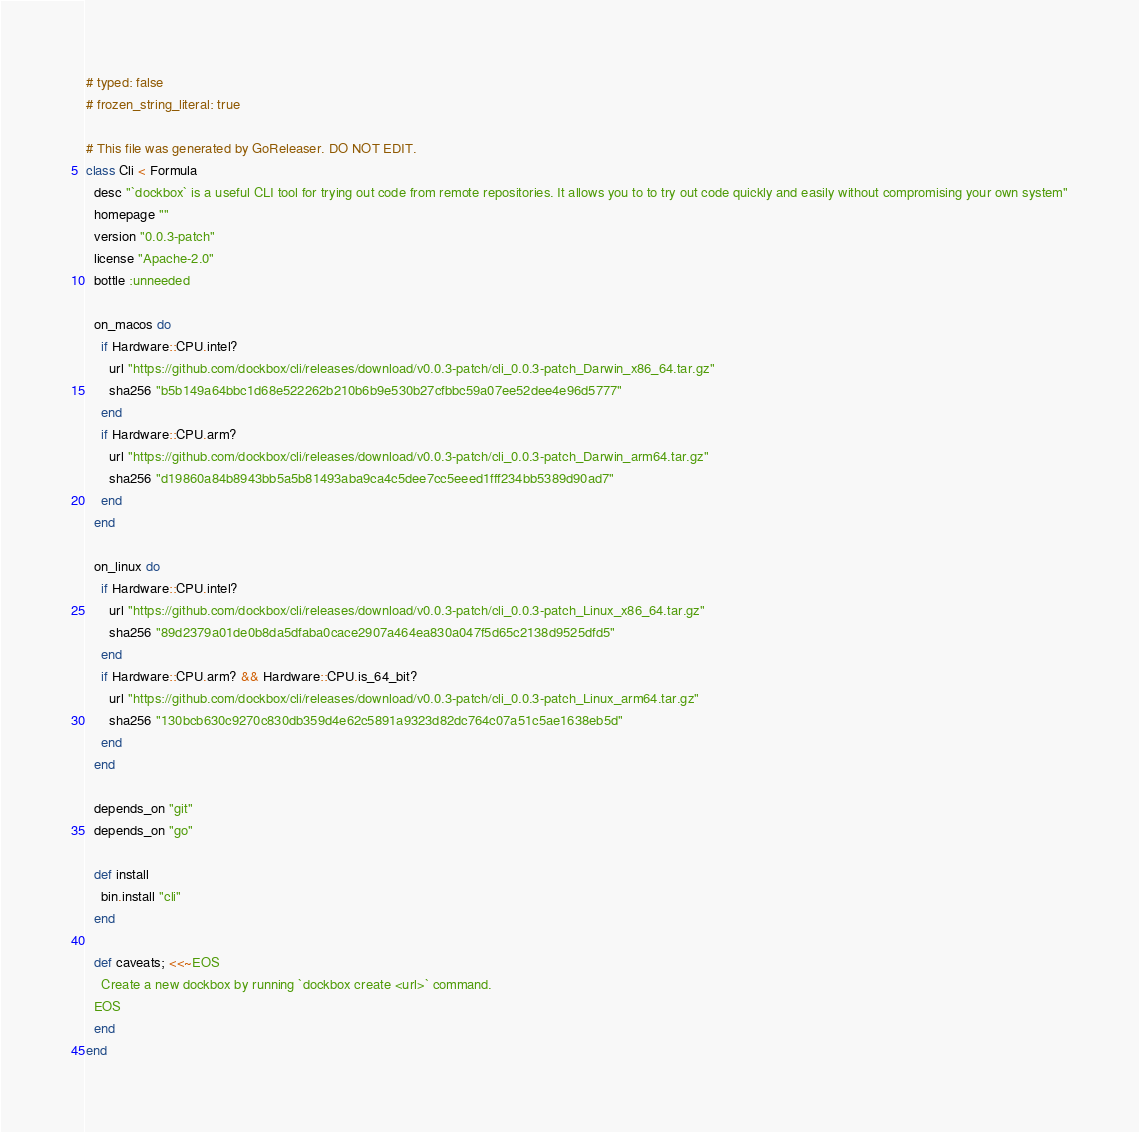Convert code to text. <code><loc_0><loc_0><loc_500><loc_500><_Ruby_># typed: false
# frozen_string_literal: true

# This file was generated by GoReleaser. DO NOT EDIT.
class Cli < Formula
  desc "`dockbox` is a useful CLI tool for trying out code from remote repositories. It allows you to to try out code quickly and easily without compromising your own system"
  homepage ""
  version "0.0.3-patch"
  license "Apache-2.0"
  bottle :unneeded

  on_macos do
    if Hardware::CPU.intel?
      url "https://github.com/dockbox/cli/releases/download/v0.0.3-patch/cli_0.0.3-patch_Darwin_x86_64.tar.gz"
      sha256 "b5b149a64bbc1d68e522262b210b6b9e530b27cfbbc59a07ee52dee4e96d5777"
    end
    if Hardware::CPU.arm?
      url "https://github.com/dockbox/cli/releases/download/v0.0.3-patch/cli_0.0.3-patch_Darwin_arm64.tar.gz"
      sha256 "d19860a84b8943bb5a5b81493aba9ca4c5dee7cc5eeed1fff234bb5389d90ad7"
    end
  end

  on_linux do
    if Hardware::CPU.intel?
      url "https://github.com/dockbox/cli/releases/download/v0.0.3-patch/cli_0.0.3-patch_Linux_x86_64.tar.gz"
      sha256 "89d2379a01de0b8da5dfaba0cace2907a464ea830a047f5d65c2138d9525dfd5"
    end
    if Hardware::CPU.arm? && Hardware::CPU.is_64_bit?
      url "https://github.com/dockbox/cli/releases/download/v0.0.3-patch/cli_0.0.3-patch_Linux_arm64.tar.gz"
      sha256 "130bcb630c9270c830db359d4e62c5891a9323d82dc764c07a51c5ae1638eb5d"
    end
  end

  depends_on "git"
  depends_on "go"

  def install
    bin.install "cli"
  end

  def caveats; <<~EOS
    Create a new dockbox by running `dockbox create <url>` command.
  EOS
  end
end
</code> 